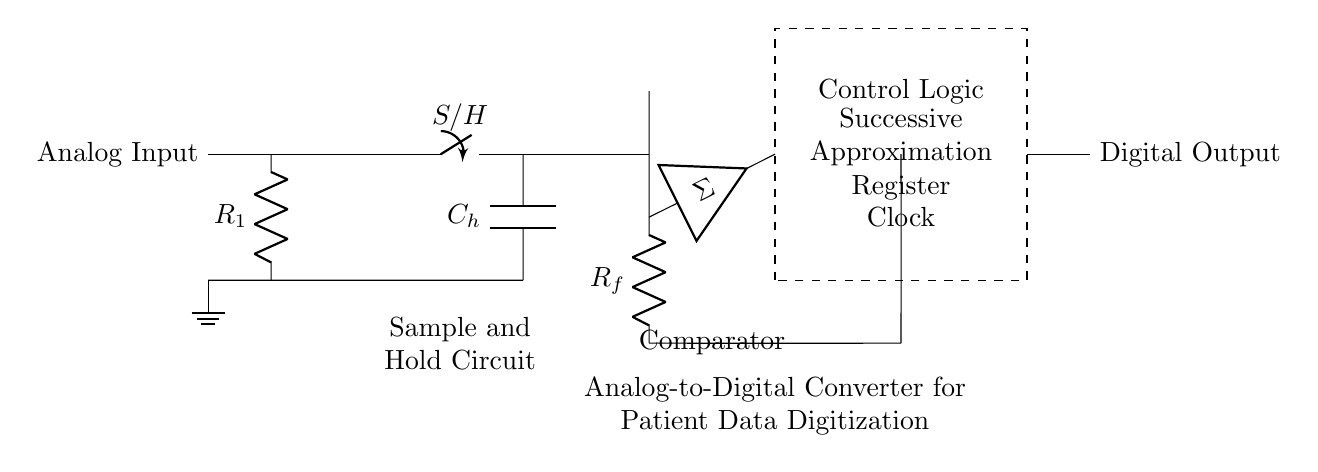What is the purpose of the component labeled C_h? The capacitor labeled C_h is part of the sample and hold circuit, which temporarily holds the sampled analog voltage for conversion while the ADC processes the signal.
Answer: Sample and hold What is the function of the switch labeled S/H? The switch labeled S/H controls when the sample and hold capacitor charges to the input voltage, allowing the circuit to stabilize the analog signal for accurate digitization.
Answer: Controls sampling What does the symbol labeled "Σ" represent? The symbol labeled "Σ" indicates an operational amplifier or comparator that compares the input signal to a reference voltage in the ADC's conversion process.
Answer: Comparator Which component provides feedback to the comparator? The resistor labeled R_f provides feedback from the output of the comparator to one of its inputs, controlling the gain and stability of the ADC process.
Answer: R_f How many stages are in the ADC as indicated by the diagram? The ADC circuit presented utilizes a successive approximation method, which involves multiple approximations, as indicated by the layout; however, the exact number of stages is typically determined by the bit resolution of the ADC, which is not explicitly indicated in the diagram.
Answer: Multiple What role does the Control Logic play in this circuit? The Control Logic coordinates the timing of the sampling, holding, and conversion processes within the ADC, ensuring that each stage operates in the correct sequence for accurate digitization of the analog input.
Answer: Coordinates operation 